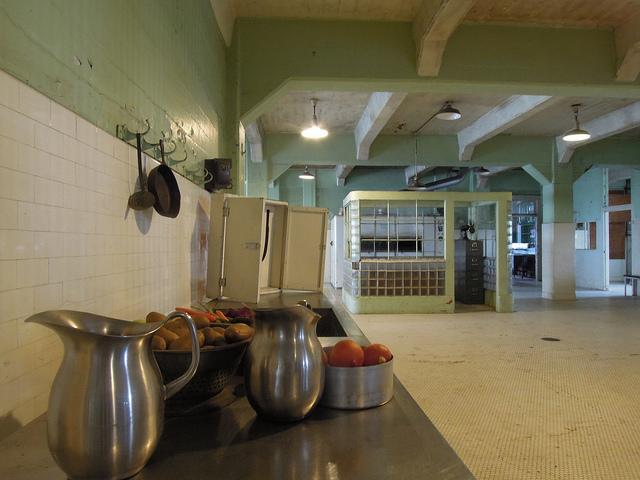Which food provides the most vitamin A? Please explain your reasoning. carrot. Carrots are high in vitamin a and the highest amount of the foods in the picture. 